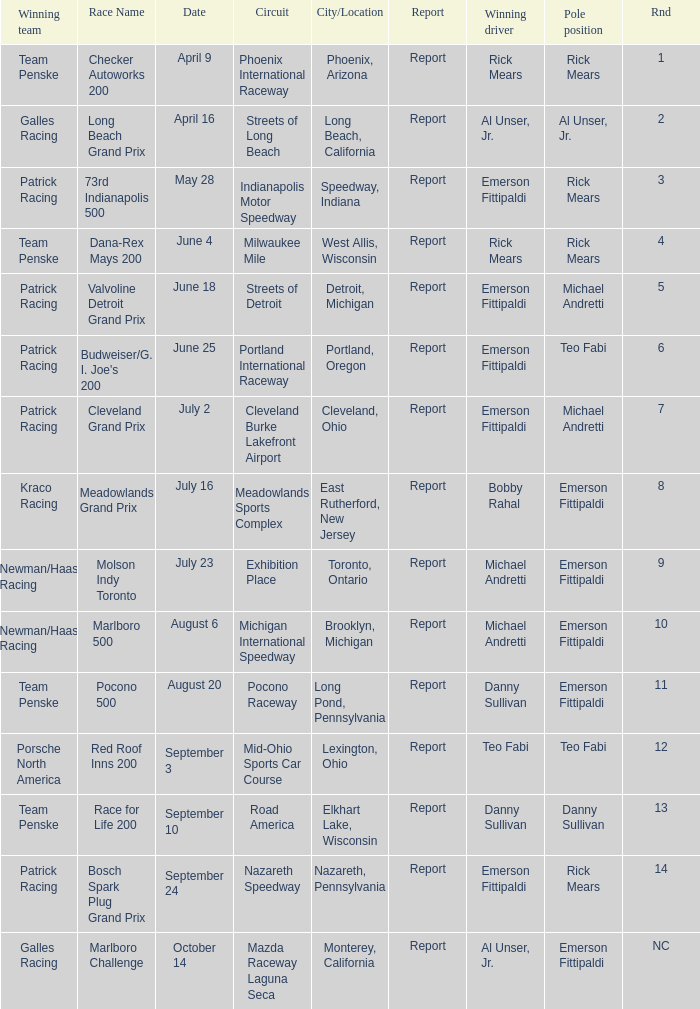Who was the pole position for the rnd equalling 12? Teo Fabi. 